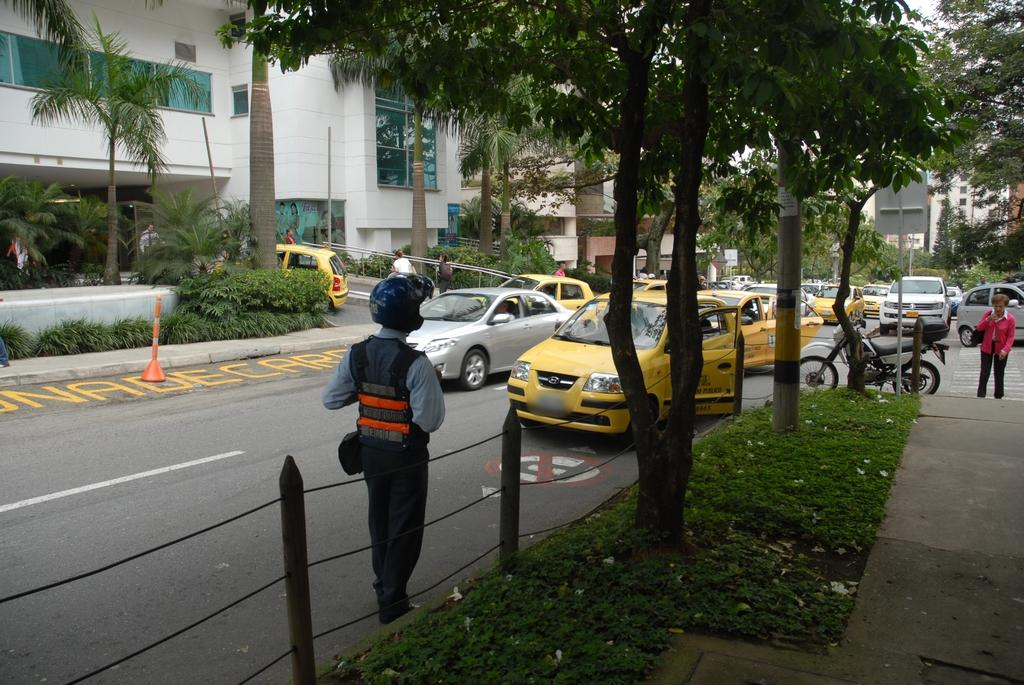What can be seen on the road in the image? There are vehicles on the road in the image. Who or what is present in the image besides the vehicles? There are people, grass, plants, trees, buildings, and rods with ropes visible in the image. Can you describe the buildings in the image? The buildings have glass windows. What type of vegetation is present in the image? Grass, plants, and trees are present in the image. What type of bait is being used by the fireman in the image? There is no fireman or bait present in the image. How are the people in the image sorting the plants? There is no sorting of plants being depicted in the image. 